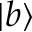Convert formula to latex. <formula><loc_0><loc_0><loc_500><loc_500>| b \rangle</formula> 